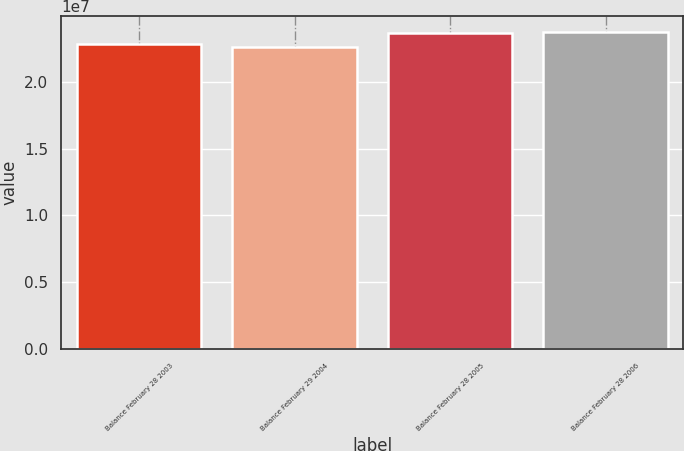Convert chart to OTSL. <chart><loc_0><loc_0><loc_500><loc_500><bar_chart><fcel>Balance February 28 2003<fcel>Balance February 29 2004<fcel>Balance February 28 2005<fcel>Balance February 28 2006<nl><fcel>2.28159e+07<fcel>2.25749e+07<fcel>2.36008e+07<fcel>2.37086e+07<nl></chart> 